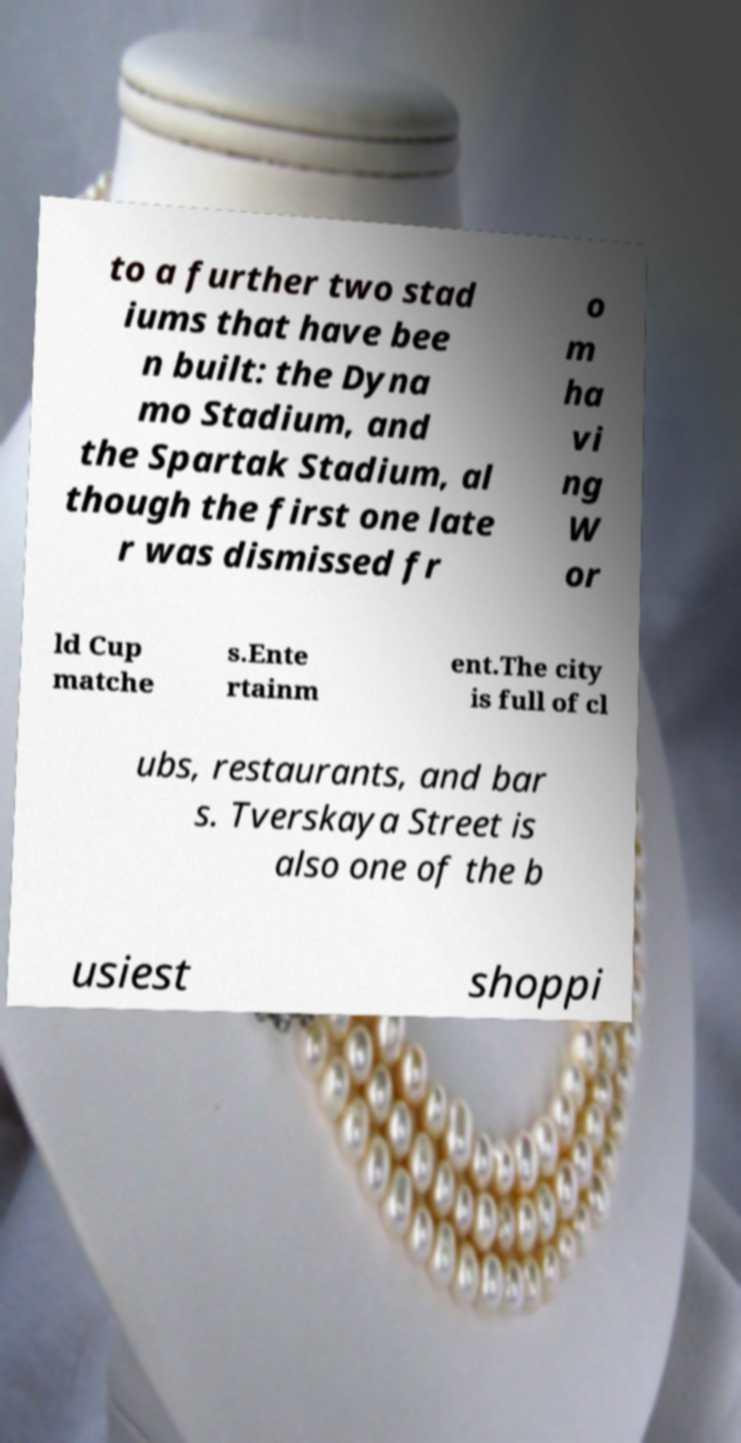I need the written content from this picture converted into text. Can you do that? to a further two stad iums that have bee n built: the Dyna mo Stadium, and the Spartak Stadium, al though the first one late r was dismissed fr o m ha vi ng W or ld Cup matche s.Ente rtainm ent.The city is full of cl ubs, restaurants, and bar s. Tverskaya Street is also one of the b usiest shoppi 